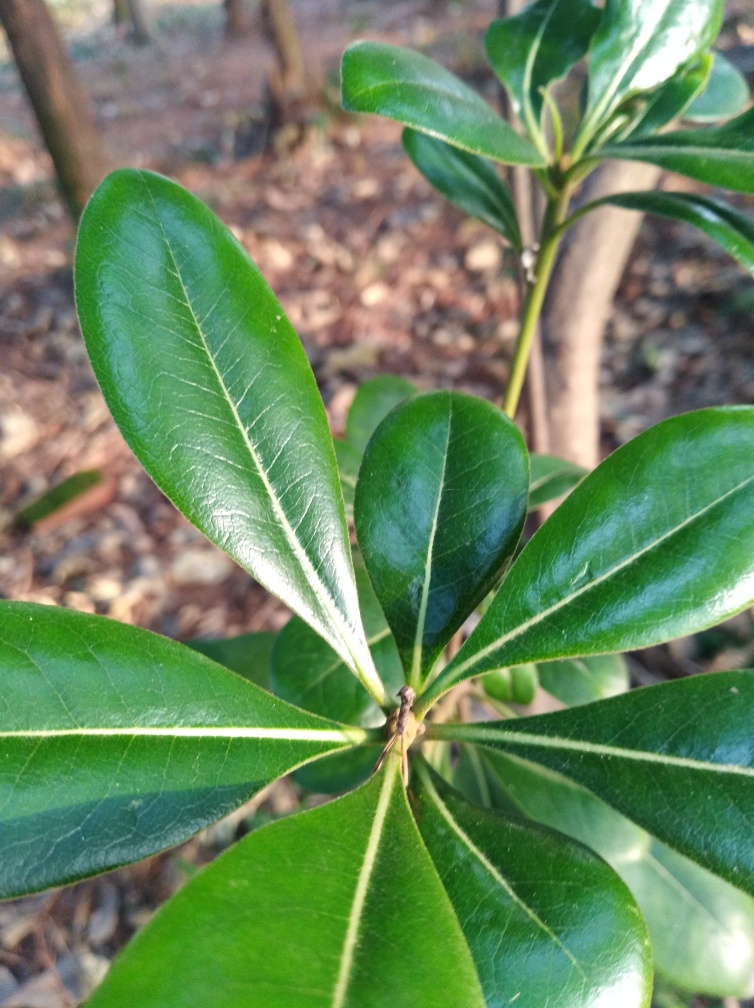Are there any quality issues related to underexposure?
A. No
B. Yes
Answer with the option's letter from the given choices directly.
 A. 